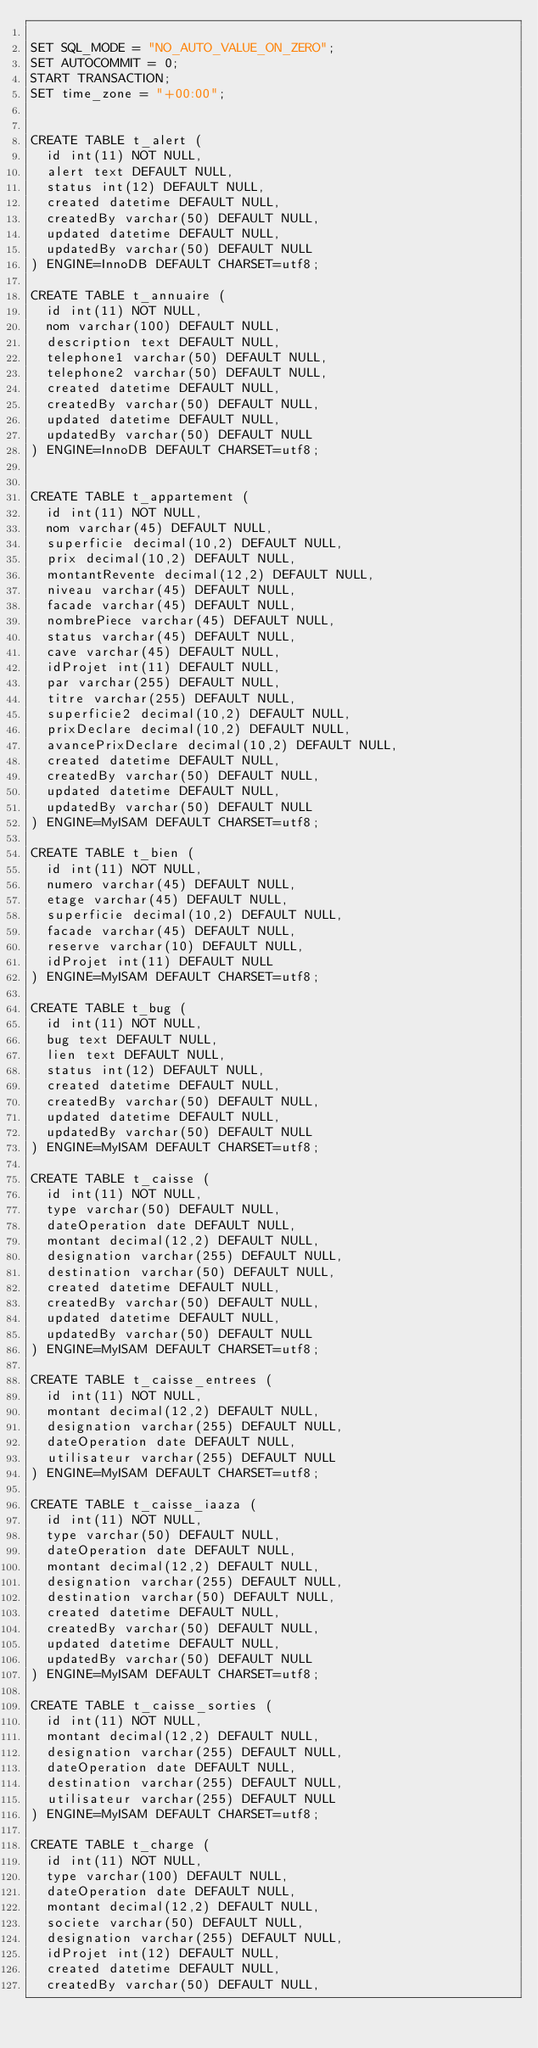<code> <loc_0><loc_0><loc_500><loc_500><_SQL_>
SET SQL_MODE = "NO_AUTO_VALUE_ON_ZERO";
SET AUTOCOMMIT = 0;
START TRANSACTION;
SET time_zone = "+00:00";


CREATE TABLE t_alert (
  id int(11) NOT NULL,
  alert text DEFAULT NULL,
  status int(12) DEFAULT NULL,
  created datetime DEFAULT NULL,
  createdBy varchar(50) DEFAULT NULL,
  updated datetime DEFAULT NULL,
  updatedBy varchar(50) DEFAULT NULL
) ENGINE=InnoDB DEFAULT CHARSET=utf8;

CREATE TABLE t_annuaire (
  id int(11) NOT NULL,
  nom varchar(100) DEFAULT NULL,
  description text DEFAULT NULL,
  telephone1 varchar(50) DEFAULT NULL,
  telephone2 varchar(50) DEFAULT NULL,
  created datetime DEFAULT NULL,
  createdBy varchar(50) DEFAULT NULL,
  updated datetime DEFAULT NULL,
  updatedBy varchar(50) DEFAULT NULL
) ENGINE=InnoDB DEFAULT CHARSET=utf8;


CREATE TABLE t_appartement (
  id int(11) NOT NULL,
  nom varchar(45) DEFAULT NULL,
  superficie decimal(10,2) DEFAULT NULL,
  prix decimal(10,2) DEFAULT NULL,
  montantRevente decimal(12,2) DEFAULT NULL,
  niveau varchar(45) DEFAULT NULL,
  facade varchar(45) DEFAULT NULL,
  nombrePiece varchar(45) DEFAULT NULL,
  status varchar(45) DEFAULT NULL,
  cave varchar(45) DEFAULT NULL,
  idProjet int(11) DEFAULT NULL,
  par varchar(255) DEFAULT NULL,
  titre varchar(255) DEFAULT NULL,
  superficie2 decimal(10,2) DEFAULT NULL,
  prixDeclare decimal(10,2) DEFAULT NULL,
  avancePrixDeclare decimal(10,2) DEFAULT NULL,
  created datetime DEFAULT NULL,
  createdBy varchar(50) DEFAULT NULL,
  updated datetime DEFAULT NULL,
  updatedBy varchar(50) DEFAULT NULL
) ENGINE=MyISAM DEFAULT CHARSET=utf8;

CREATE TABLE t_bien (
  id int(11) NOT NULL,
  numero varchar(45) DEFAULT NULL,
  etage varchar(45) DEFAULT NULL,
  superficie decimal(10,2) DEFAULT NULL,
  facade varchar(45) DEFAULT NULL,
  reserve varchar(10) DEFAULT NULL,
  idProjet int(11) DEFAULT NULL
) ENGINE=MyISAM DEFAULT CHARSET=utf8;

CREATE TABLE t_bug (
  id int(11) NOT NULL,
  bug text DEFAULT NULL,
  lien text DEFAULT NULL,
  status int(12) DEFAULT NULL,
  created datetime DEFAULT NULL,
  createdBy varchar(50) DEFAULT NULL,
  updated datetime DEFAULT NULL,
  updatedBy varchar(50) DEFAULT NULL
) ENGINE=MyISAM DEFAULT CHARSET=utf8;

CREATE TABLE t_caisse (
  id int(11) NOT NULL,
  type varchar(50) DEFAULT NULL,
  dateOperation date DEFAULT NULL,
  montant decimal(12,2) DEFAULT NULL,
  designation varchar(255) DEFAULT NULL,
  destination varchar(50) DEFAULT NULL,
  created datetime DEFAULT NULL,
  createdBy varchar(50) DEFAULT NULL,
  updated datetime DEFAULT NULL,
  updatedBy varchar(50) DEFAULT NULL
) ENGINE=MyISAM DEFAULT CHARSET=utf8;

CREATE TABLE t_caisse_entrees (
  id int(11) NOT NULL,
  montant decimal(12,2) DEFAULT NULL,
  designation varchar(255) DEFAULT NULL,
  dateOperation date DEFAULT NULL,
  utilisateur varchar(255) DEFAULT NULL
) ENGINE=MyISAM DEFAULT CHARSET=utf8;

CREATE TABLE t_caisse_iaaza (
  id int(11) NOT NULL,
  type varchar(50) DEFAULT NULL,
  dateOperation date DEFAULT NULL,
  montant decimal(12,2) DEFAULT NULL,
  designation varchar(255) DEFAULT NULL,
  destination varchar(50) DEFAULT NULL,
  created datetime DEFAULT NULL,
  createdBy varchar(50) DEFAULT NULL,
  updated datetime DEFAULT NULL,
  updatedBy varchar(50) DEFAULT NULL
) ENGINE=MyISAM DEFAULT CHARSET=utf8;

CREATE TABLE t_caisse_sorties (
  id int(11) NOT NULL,
  montant decimal(12,2) DEFAULT NULL,
  designation varchar(255) DEFAULT NULL,
  dateOperation date DEFAULT NULL,
  destination varchar(255) DEFAULT NULL,
  utilisateur varchar(255) DEFAULT NULL
) ENGINE=MyISAM DEFAULT CHARSET=utf8;

CREATE TABLE t_charge (
  id int(11) NOT NULL,
  type varchar(100) DEFAULT NULL,
  dateOperation date DEFAULT NULL,
  montant decimal(12,2) DEFAULT NULL,
  societe varchar(50) DEFAULT NULL,
  designation varchar(255) DEFAULT NULL,
  idProjet int(12) DEFAULT NULL,
  created datetime DEFAULT NULL,
  createdBy varchar(50) DEFAULT NULL,</code> 